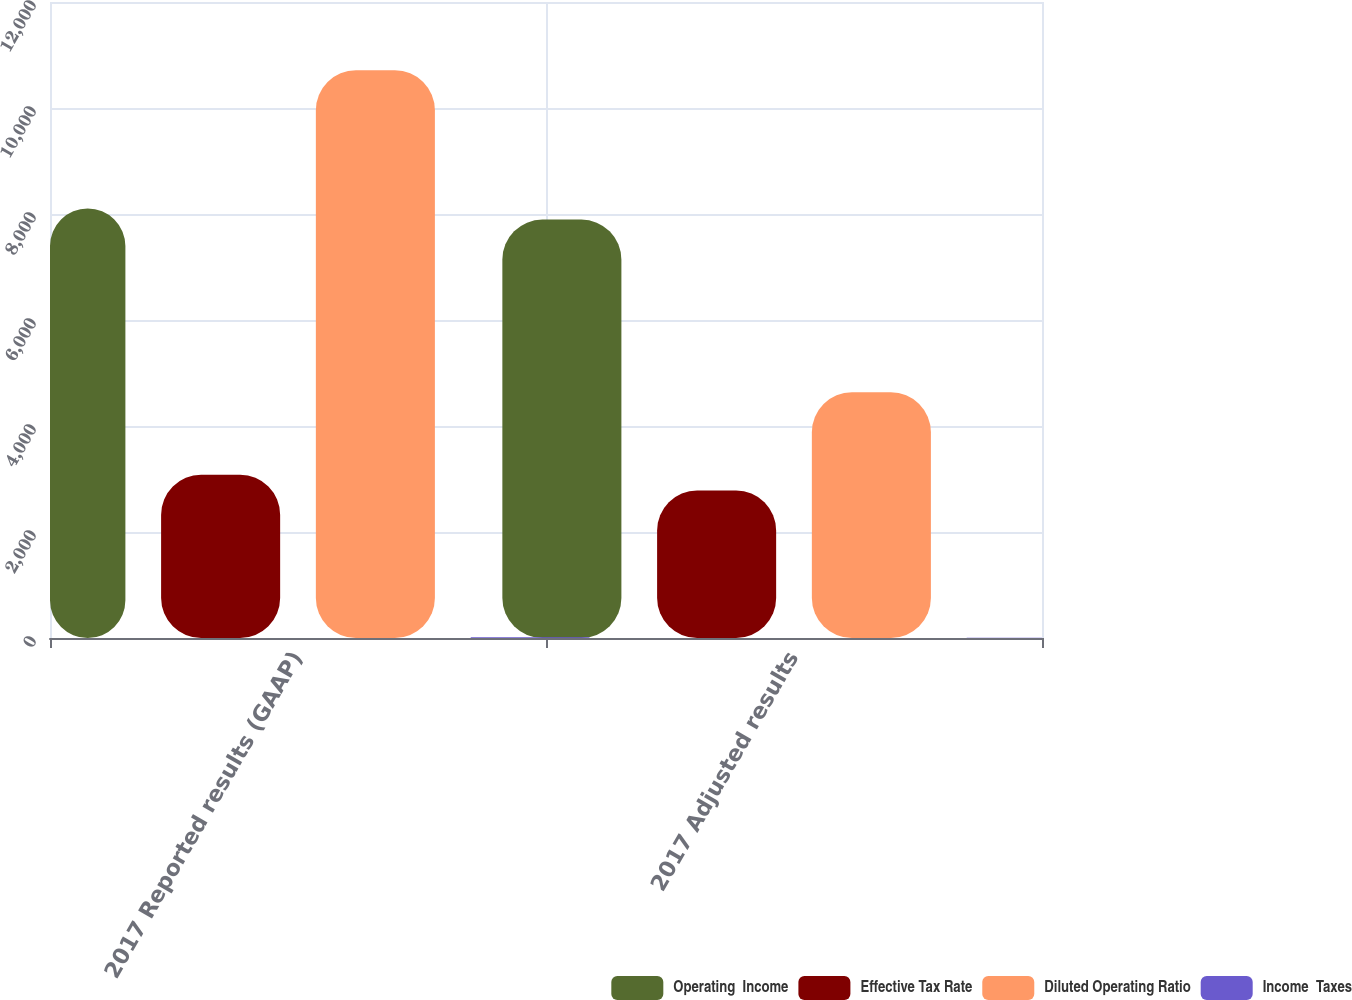<chart> <loc_0><loc_0><loc_500><loc_500><stacked_bar_chart><ecel><fcel>2017 Reported results (GAAP)<fcel>2017 Adjusted results<nl><fcel>Operating  Income<fcel>8106<fcel>7894<nl><fcel>Effective Tax Rate<fcel>3080<fcel>2782<nl><fcel>Diluted Operating Ratio<fcel>10712<fcel>4638<nl><fcel>Income  Taxes<fcel>13.36<fcel>5.79<nl></chart> 